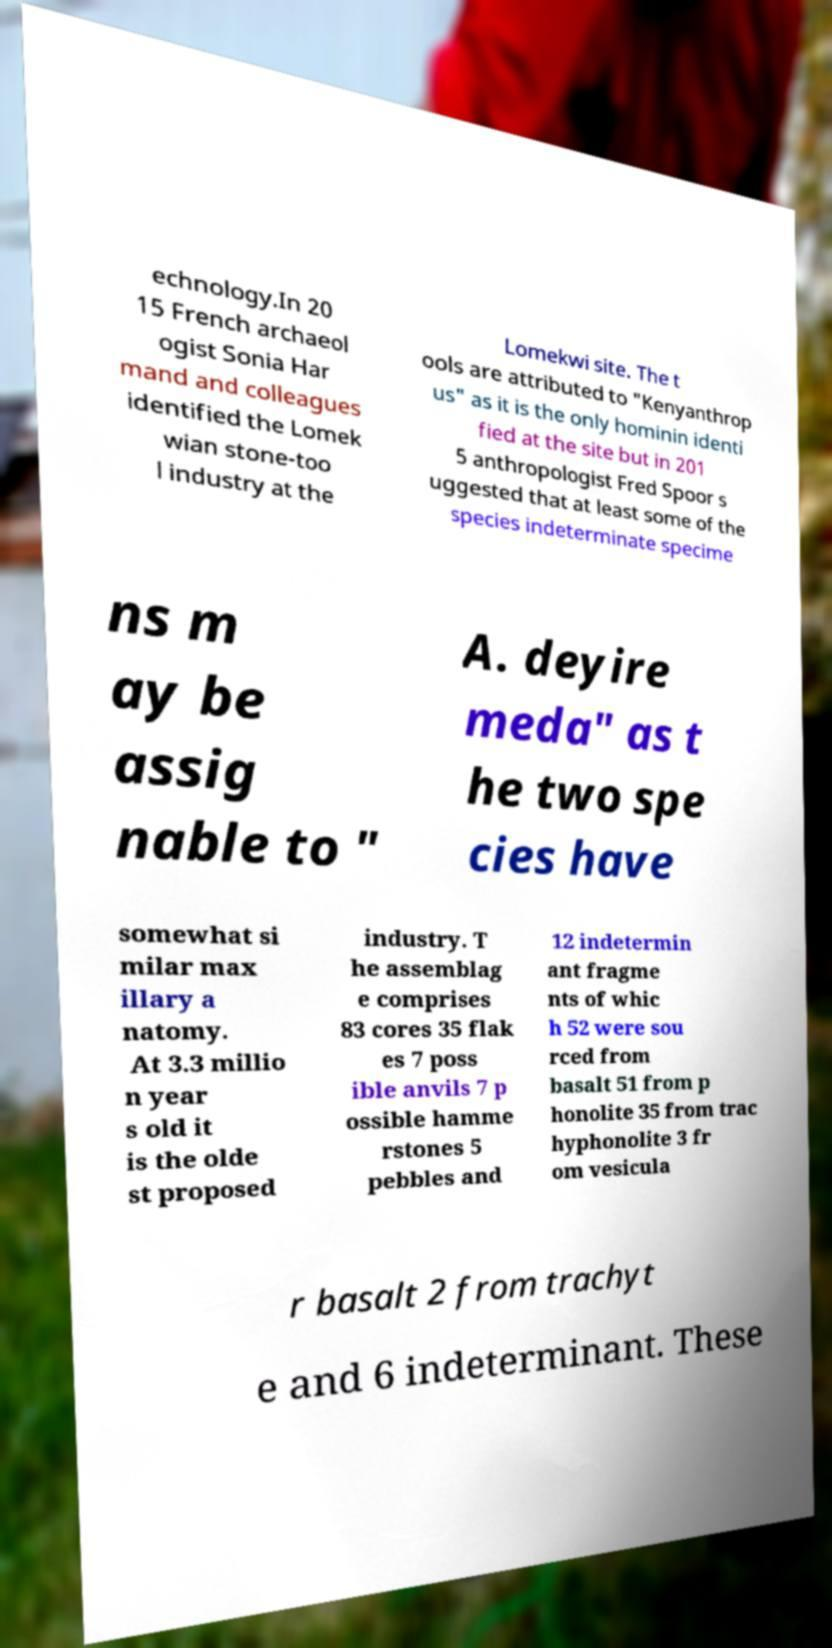Please identify and transcribe the text found in this image. echnology.In 20 15 French archaeol ogist Sonia Har mand and colleagues identified the Lomek wian stone-too l industry at the Lomekwi site. The t ools are attributed to "Kenyanthrop us" as it is the only hominin identi fied at the site but in 201 5 anthropologist Fred Spoor s uggested that at least some of the species indeterminate specime ns m ay be assig nable to " A. deyire meda" as t he two spe cies have somewhat si milar max illary a natomy. At 3.3 millio n year s old it is the olde st proposed industry. T he assemblag e comprises 83 cores 35 flak es 7 poss ible anvils 7 p ossible hamme rstones 5 pebbles and 12 indetermin ant fragme nts of whic h 52 were sou rced from basalt 51 from p honolite 35 from trac hyphonolite 3 fr om vesicula r basalt 2 from trachyt e and 6 indeterminant. These 